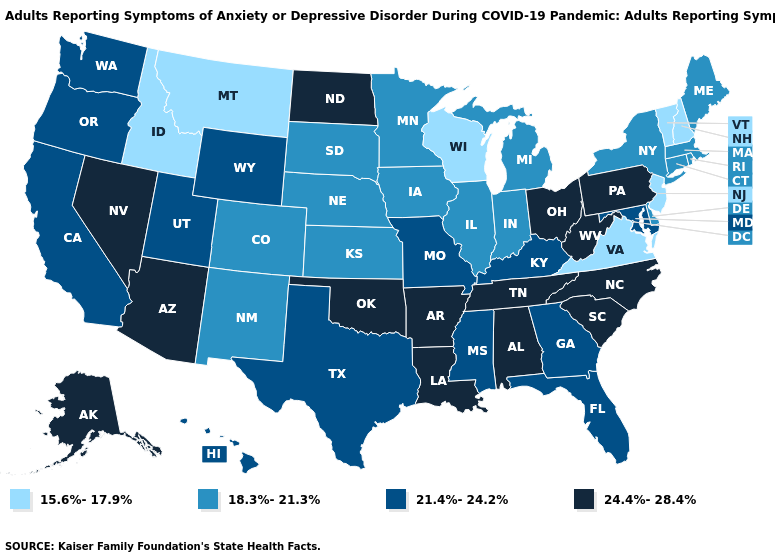What is the value of Florida?
Answer briefly. 21.4%-24.2%. Name the states that have a value in the range 15.6%-17.9%?
Write a very short answer. Idaho, Montana, New Hampshire, New Jersey, Vermont, Virginia, Wisconsin. Which states have the lowest value in the West?
Answer briefly. Idaho, Montana. Name the states that have a value in the range 21.4%-24.2%?
Answer briefly. California, Florida, Georgia, Hawaii, Kentucky, Maryland, Mississippi, Missouri, Oregon, Texas, Utah, Washington, Wyoming. Among the states that border Washington , does Idaho have the lowest value?
Concise answer only. Yes. Is the legend a continuous bar?
Keep it brief. No. Does West Virginia have the lowest value in the USA?
Be succinct. No. Among the states that border Nebraska , which have the lowest value?
Quick response, please. Colorado, Iowa, Kansas, South Dakota. Does the first symbol in the legend represent the smallest category?
Quick response, please. Yes. Name the states that have a value in the range 15.6%-17.9%?
Quick response, please. Idaho, Montana, New Hampshire, New Jersey, Vermont, Virginia, Wisconsin. Does Mississippi have a lower value than Utah?
Answer briefly. No. What is the highest value in states that border Utah?
Short answer required. 24.4%-28.4%. What is the value of Rhode Island?
Quick response, please. 18.3%-21.3%. Does Louisiana have the highest value in the USA?
Quick response, please. Yes. Does New York have the highest value in the USA?
Quick response, please. No. 